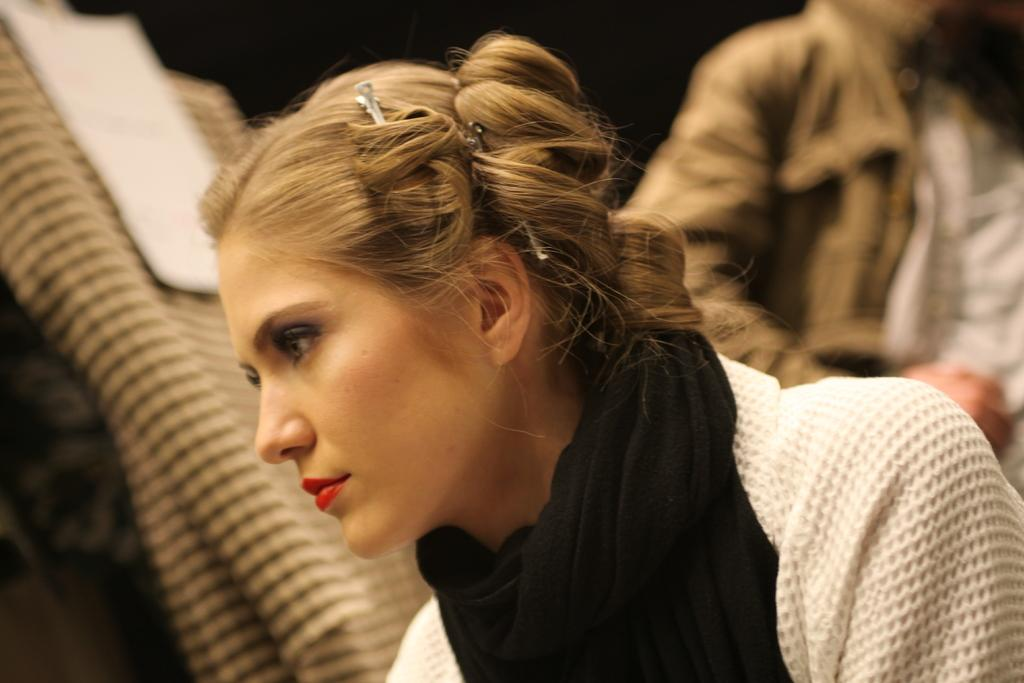How many people are in the image? There are two persons in the image. Can you describe the gender of the people in the image? One of the persons is a man, and the other person is a woman. What type of tiger can be seen in the image? There is no tiger present in the image; it features two people, a man and a woman. What suggestion is being made by the woman in the image? The image does not provide any information about a suggestion being made by the woman. 